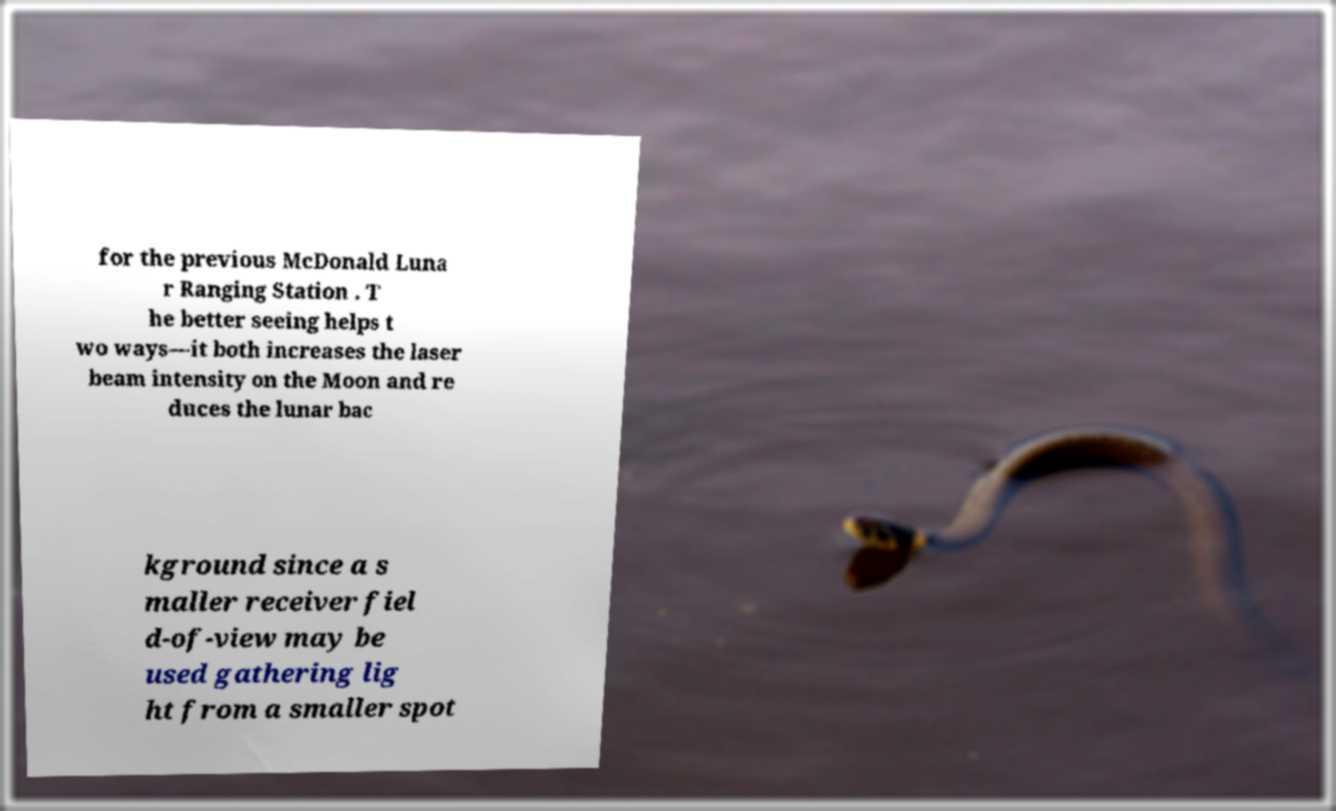I need the written content from this picture converted into text. Can you do that? for the previous McDonald Luna r Ranging Station . T he better seeing helps t wo ways—it both increases the laser beam intensity on the Moon and re duces the lunar bac kground since a s maller receiver fiel d-of-view may be used gathering lig ht from a smaller spot 